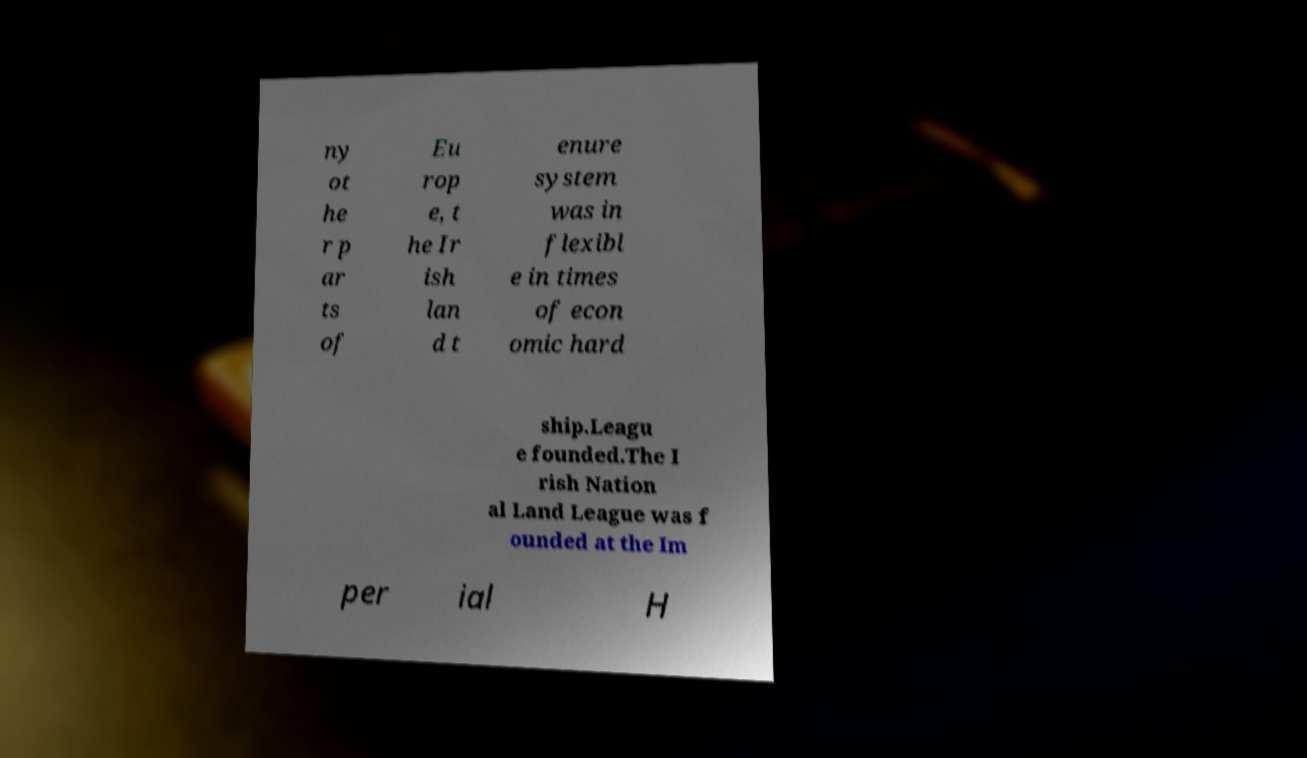For documentation purposes, I need the text within this image transcribed. Could you provide that? ny ot he r p ar ts of Eu rop e, t he Ir ish lan d t enure system was in flexibl e in times of econ omic hard ship.Leagu e founded.The I rish Nation al Land League was f ounded at the Im per ial H 